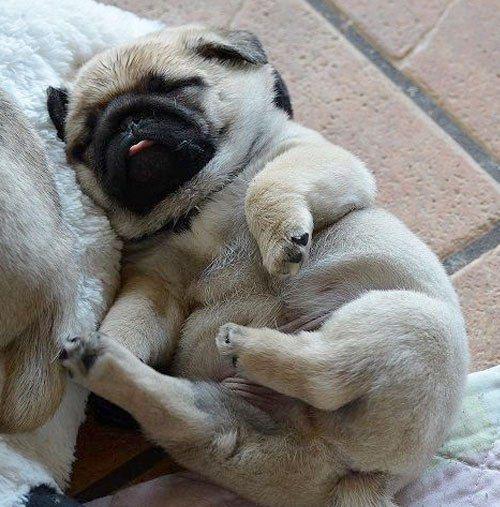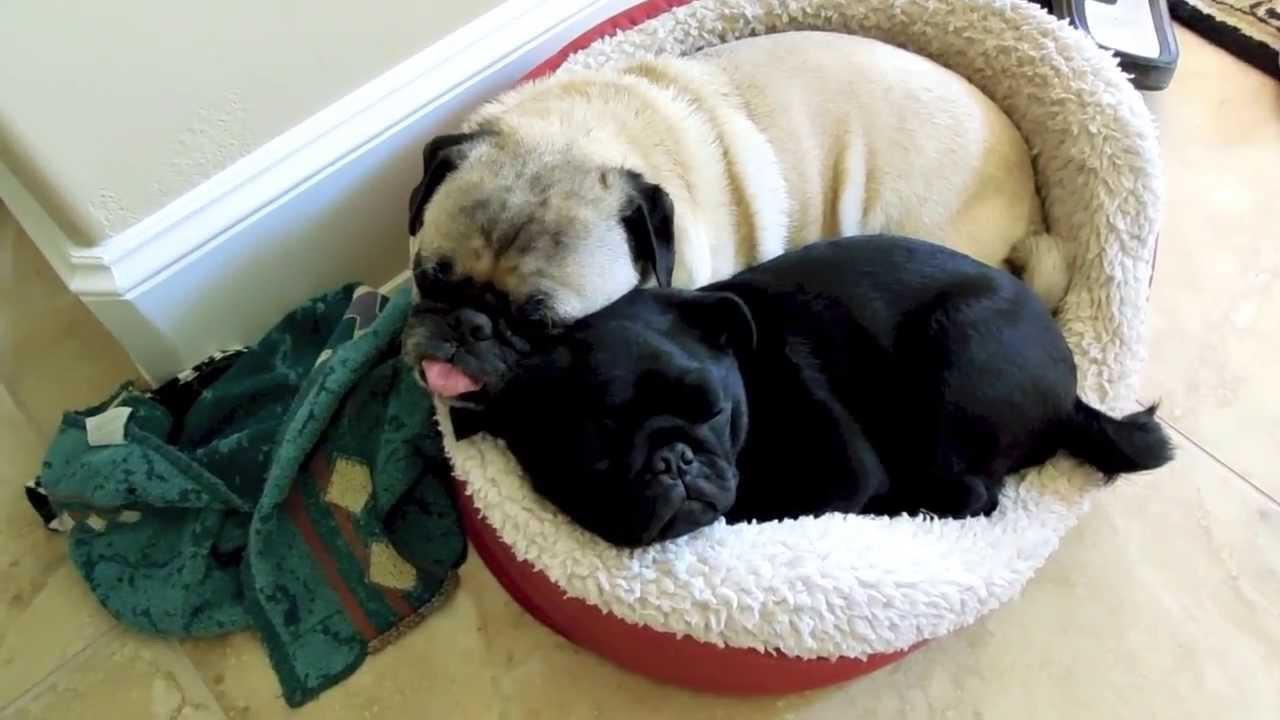The first image is the image on the left, the second image is the image on the right. Examine the images to the left and right. Is the description "Each image shows one dog lounging on a soft cushioned surface." accurate? Answer yes or no. No. 